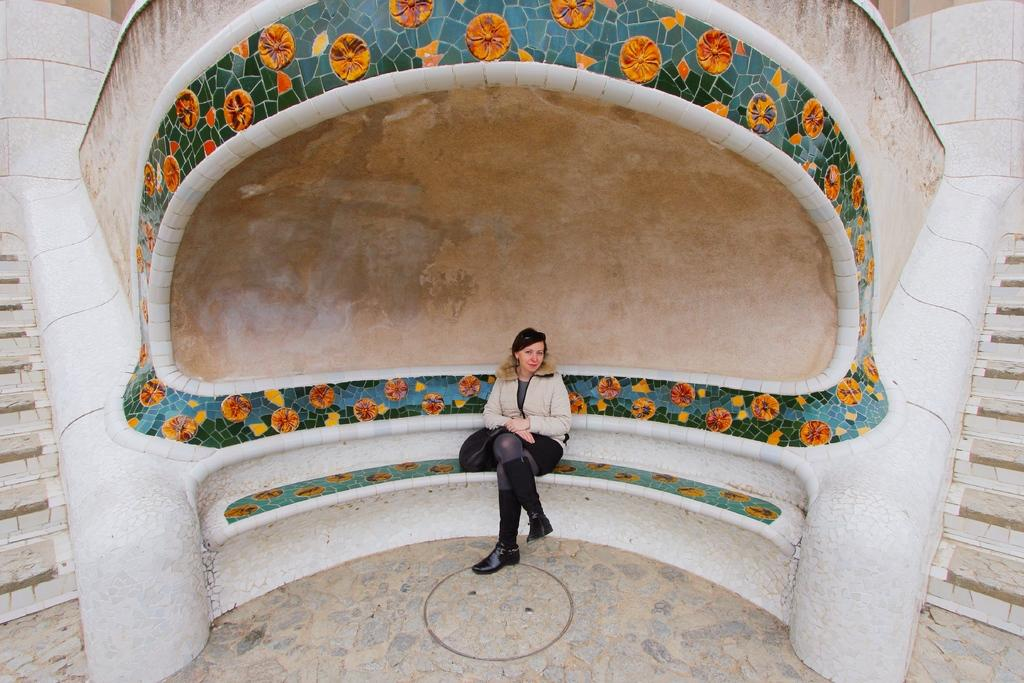What is the woman doing in the image? The woman is sitting on a platform in the image. What can be seen behind the woman? There is a wall in the image. Are there any architectural features in the image? Yes, there are steps in the image. What type of rod is the beggar using to catch fish in the image? There is no beggar or rod present in the image; it only features a woman sitting on a platform with a wall and steps in the background. 